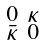<formula> <loc_0><loc_0><loc_500><loc_500>\begin{smallmatrix} 0 & \kappa \\ \bar { \kappa } & 0 \end{smallmatrix}</formula> 